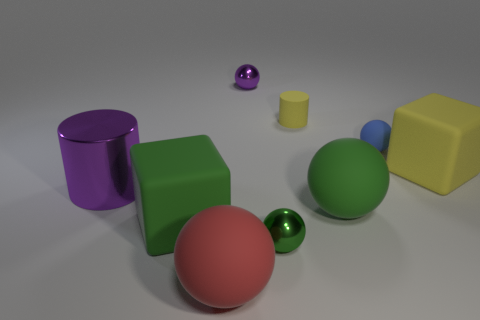Subtract 1 spheres. How many spheres are left? 4 Subtract all purple spheres. How many spheres are left? 4 Subtract all blue spheres. How many spheres are left? 4 Subtract all yellow spheres. Subtract all blue blocks. How many spheres are left? 5 Subtract all cylinders. How many objects are left? 7 Subtract all small gray shiny objects. Subtract all big red rubber spheres. How many objects are left? 8 Add 4 tiny purple spheres. How many tiny purple spheres are left? 5 Add 3 purple things. How many purple things exist? 5 Subtract 2 green spheres. How many objects are left? 7 